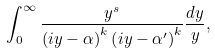<formula> <loc_0><loc_0><loc_500><loc_500>\int _ { 0 } ^ { \infty } \frac { y ^ { s } } { \left ( i y - \alpha \right ) ^ { k } \left ( i y - \alpha ^ { \prime } \right ) ^ { k } } \frac { d y } { y } ,</formula> 